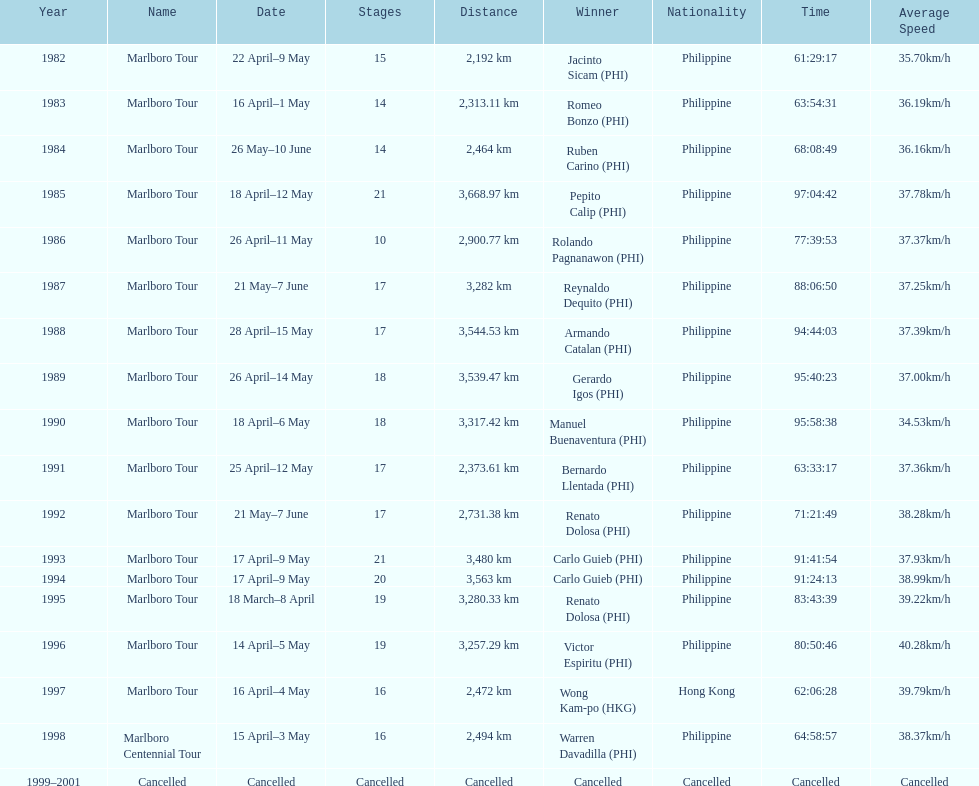Who won the most marlboro tours? Carlo Guieb. 